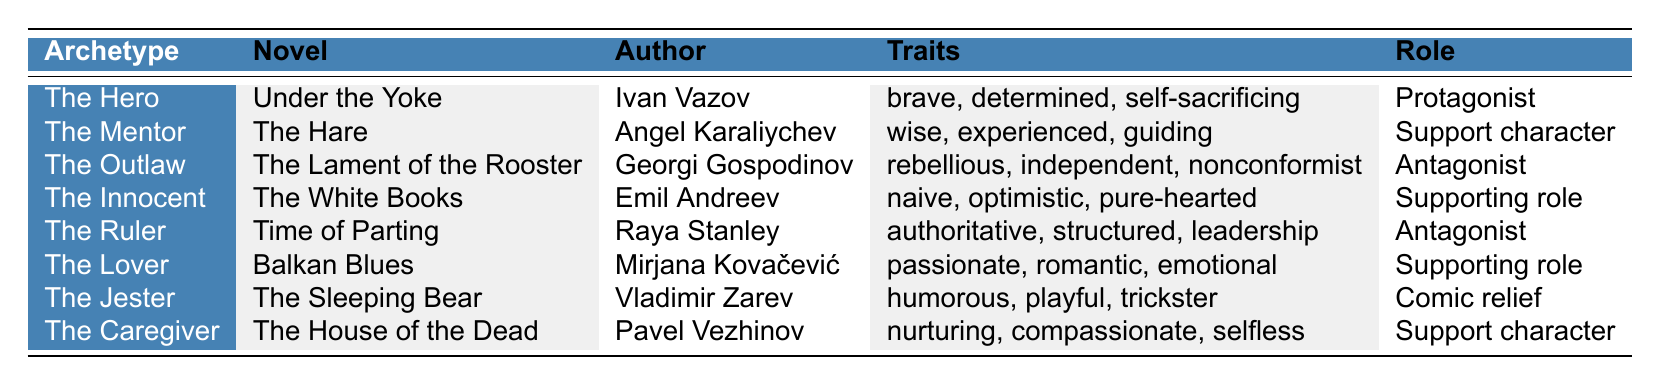What is the name of the protagonist in "Under the Yoke"? The table lists "The Hero" as the archetype for the novel "Under the Yoke" by Ivan Vazov, and further indicates that this character is classified as the protagonist role.
Answer: The Hero Which character archetype is portrayed by Mirjana Kovačević in "Balkan Blues"? The table shows that "Balkan Blues" is associated with the archetype "The Lover," written by Mirjana Kovačević. Therefore, "The Lover" is the character archetype for this novel.
Answer: The Lover Is there a character labeled as "The Jester" in the novels listed? According to the table, "The Jester" appears in "The Sleeping Bear" by Vladimir Zarev, confirming the presence of this character archetype.
Answer: Yes How many different roles are presented for the character archetypes? The roles given in the table are: Protagonist, Support character, Antagonist, Supporting role, and Comic relief, which total to five distinct roles appearing across the character archetypes.
Answer: Five roles Which archetype has characteristics associated with nurturing and compassion? In the table, "The Caregiver," featured in "The House of the Dead" by Pavel Vezhinov, is identified with traits like nurturing and compassionate, indicating that this archetype is linked to those characteristics.
Answer: The Caregiver How many character archetypes are portrayed as antagonists in the novels? The table identifies two archetypes labeled as antagonists: "The Outlaw" from "The Lament of the Rooster" and "The Ruler" from "Time of Parting." Therefore, there are two antagonist archetypes represented.
Answer: Two archetypes Which character archetype has the trait of being "rebellious"? In the data presented, "The Outlaw" from "The Lament of the Rooster" is categorized with the trait "rebellious," indicating that this archetype embodies that particular quality.
Answer: The Outlaw What combination of traits belongs to the character labeled as "The Innocent"? The table lists the traits of "The Innocent" as naive, optimistic, and pure-hearted, which gives a clear combination of qualities belonging to this archetype.
Answer: Naive, optimistic, pure-hearted 